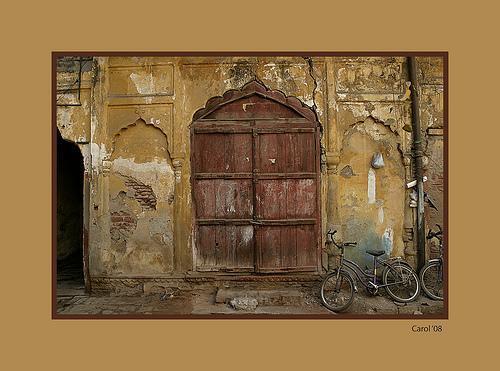How many vehicles are there?
Give a very brief answer. 2. 